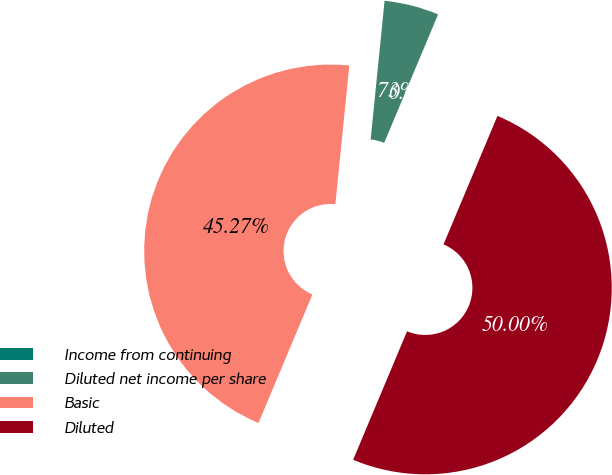Convert chart. <chart><loc_0><loc_0><loc_500><loc_500><pie_chart><fcel>Income from continuing<fcel>Diluted net income per share<fcel>Basic<fcel>Diluted<nl><fcel>0.0%<fcel>4.73%<fcel>45.27%<fcel>50.0%<nl></chart> 